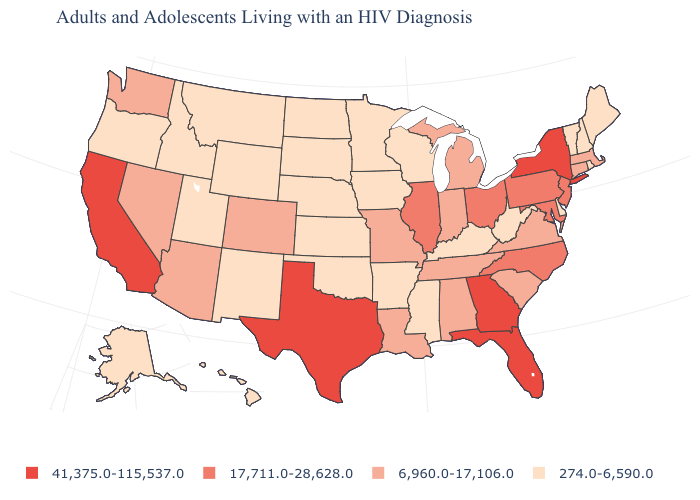Does Vermont have the lowest value in the USA?
Concise answer only. Yes. What is the value of Wisconsin?
Answer briefly. 274.0-6,590.0. What is the value of Wyoming?
Keep it brief. 274.0-6,590.0. What is the value of Wyoming?
Short answer required. 274.0-6,590.0. Name the states that have a value in the range 274.0-6,590.0?
Keep it brief. Alaska, Arkansas, Delaware, Hawaii, Idaho, Iowa, Kansas, Kentucky, Maine, Minnesota, Mississippi, Montana, Nebraska, New Hampshire, New Mexico, North Dakota, Oklahoma, Oregon, Rhode Island, South Dakota, Utah, Vermont, West Virginia, Wisconsin, Wyoming. Among the states that border New Mexico , does Utah have the lowest value?
Keep it brief. Yes. What is the value of New Jersey?
Write a very short answer. 17,711.0-28,628.0. Name the states that have a value in the range 274.0-6,590.0?
Be succinct. Alaska, Arkansas, Delaware, Hawaii, Idaho, Iowa, Kansas, Kentucky, Maine, Minnesota, Mississippi, Montana, Nebraska, New Hampshire, New Mexico, North Dakota, Oklahoma, Oregon, Rhode Island, South Dakota, Utah, Vermont, West Virginia, Wisconsin, Wyoming. Which states have the lowest value in the USA?
Quick response, please. Alaska, Arkansas, Delaware, Hawaii, Idaho, Iowa, Kansas, Kentucky, Maine, Minnesota, Mississippi, Montana, Nebraska, New Hampshire, New Mexico, North Dakota, Oklahoma, Oregon, Rhode Island, South Dakota, Utah, Vermont, West Virginia, Wisconsin, Wyoming. What is the value of Idaho?
Quick response, please. 274.0-6,590.0. Is the legend a continuous bar?
Be succinct. No. What is the value of West Virginia?
Keep it brief. 274.0-6,590.0. What is the value of Iowa?
Answer briefly. 274.0-6,590.0. Does Arkansas have the lowest value in the South?
Give a very brief answer. Yes. What is the value of Georgia?
Concise answer only. 41,375.0-115,537.0. 